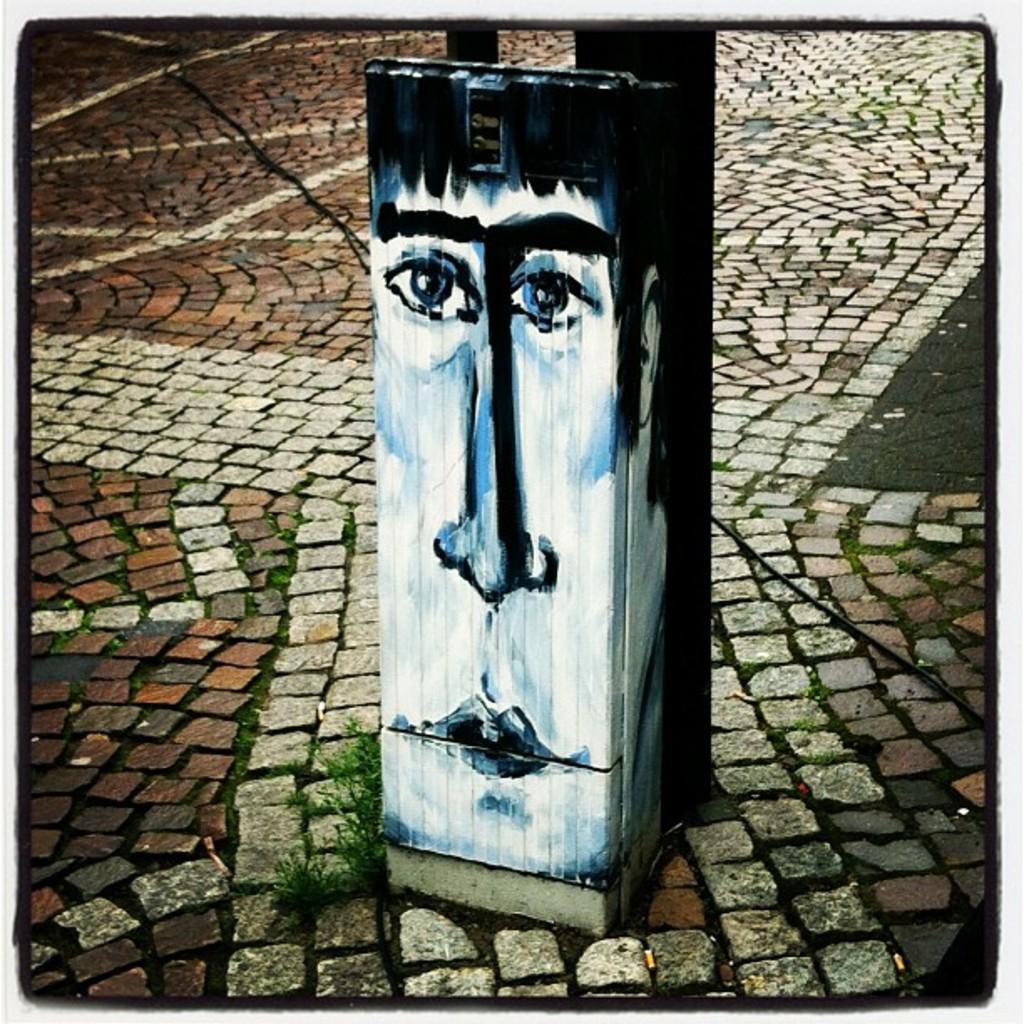Can you describe this image briefly? In this image there is ground, there is a plant on the ground, there is a wooden object, there is a painting of a face on the wooden object. 